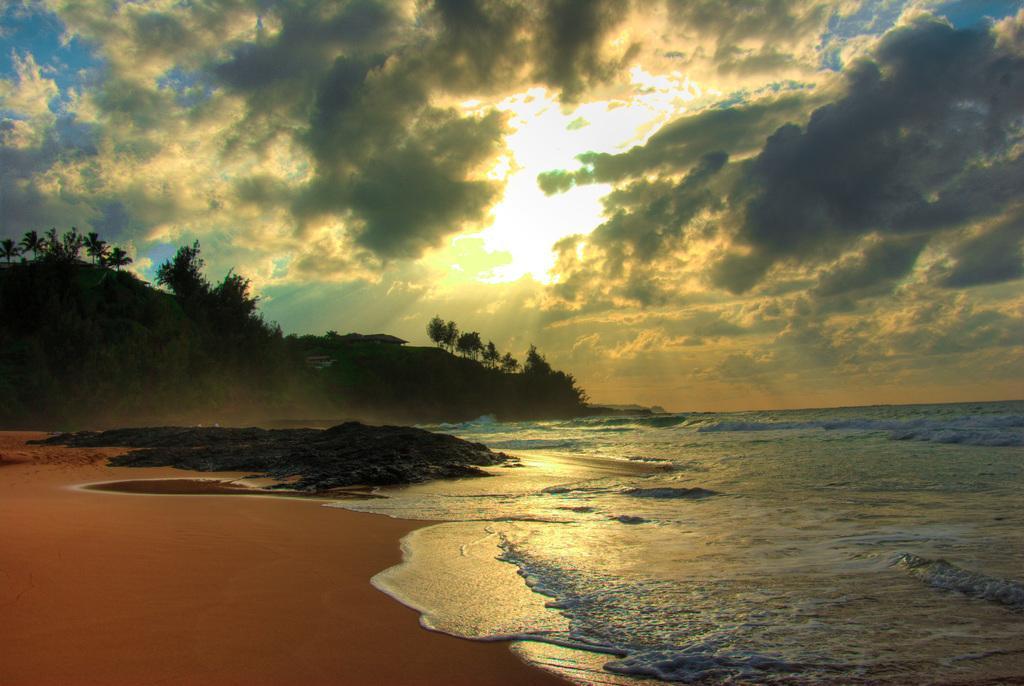Describe this image in one or two sentences. In this image at the bottom, there are waves, water, sand. In the middle there are hills, trees, sky, sun, clouds. 